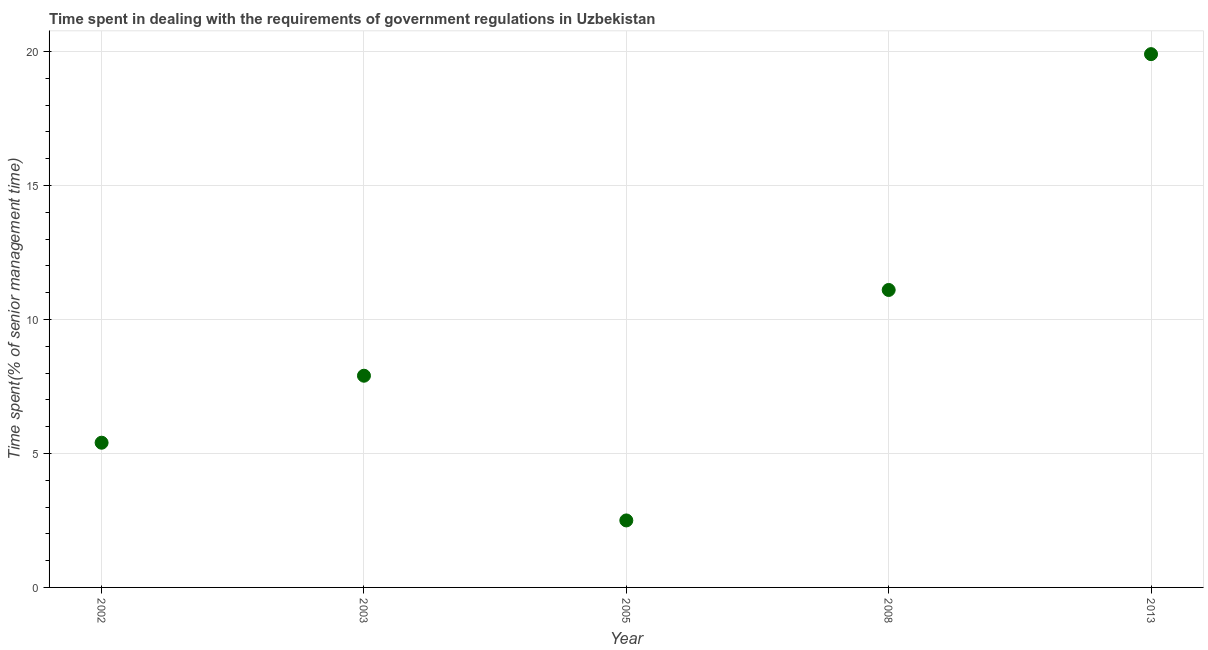What is the time spent in dealing with government regulations in 2013?
Ensure brevity in your answer.  19.9. Across all years, what is the maximum time spent in dealing with government regulations?
Provide a succinct answer. 19.9. Across all years, what is the minimum time spent in dealing with government regulations?
Your answer should be compact. 2.5. What is the sum of the time spent in dealing with government regulations?
Offer a terse response. 46.8. What is the difference between the time spent in dealing with government regulations in 2002 and 2008?
Offer a very short reply. -5.7. What is the average time spent in dealing with government regulations per year?
Offer a terse response. 9.36. What is the ratio of the time spent in dealing with government regulations in 2002 to that in 2008?
Provide a succinct answer. 0.49. Is the time spent in dealing with government regulations in 2005 less than that in 2008?
Ensure brevity in your answer.  Yes. What is the difference between the highest and the second highest time spent in dealing with government regulations?
Offer a terse response. 8.8. In how many years, is the time spent in dealing with government regulations greater than the average time spent in dealing with government regulations taken over all years?
Your answer should be compact. 2. Does the time spent in dealing with government regulations monotonically increase over the years?
Your answer should be compact. No. What is the difference between two consecutive major ticks on the Y-axis?
Your answer should be compact. 5. What is the title of the graph?
Ensure brevity in your answer.  Time spent in dealing with the requirements of government regulations in Uzbekistan. What is the label or title of the Y-axis?
Your response must be concise. Time spent(% of senior management time). What is the Time spent(% of senior management time) in 2005?
Provide a succinct answer. 2.5. What is the difference between the Time spent(% of senior management time) in 2002 and 2003?
Provide a succinct answer. -2.5. What is the difference between the Time spent(% of senior management time) in 2002 and 2005?
Make the answer very short. 2.9. What is the difference between the Time spent(% of senior management time) in 2002 and 2013?
Your answer should be compact. -14.5. What is the difference between the Time spent(% of senior management time) in 2003 and 2005?
Provide a succinct answer. 5.4. What is the difference between the Time spent(% of senior management time) in 2005 and 2013?
Give a very brief answer. -17.4. What is the difference between the Time spent(% of senior management time) in 2008 and 2013?
Keep it short and to the point. -8.8. What is the ratio of the Time spent(% of senior management time) in 2002 to that in 2003?
Keep it short and to the point. 0.68. What is the ratio of the Time spent(% of senior management time) in 2002 to that in 2005?
Make the answer very short. 2.16. What is the ratio of the Time spent(% of senior management time) in 2002 to that in 2008?
Give a very brief answer. 0.49. What is the ratio of the Time spent(% of senior management time) in 2002 to that in 2013?
Offer a very short reply. 0.27. What is the ratio of the Time spent(% of senior management time) in 2003 to that in 2005?
Provide a short and direct response. 3.16. What is the ratio of the Time spent(% of senior management time) in 2003 to that in 2008?
Your answer should be very brief. 0.71. What is the ratio of the Time spent(% of senior management time) in 2003 to that in 2013?
Give a very brief answer. 0.4. What is the ratio of the Time spent(% of senior management time) in 2005 to that in 2008?
Provide a short and direct response. 0.23. What is the ratio of the Time spent(% of senior management time) in 2005 to that in 2013?
Make the answer very short. 0.13. What is the ratio of the Time spent(% of senior management time) in 2008 to that in 2013?
Make the answer very short. 0.56. 